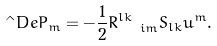Convert formula to latex. <formula><loc_0><loc_0><loc_500><loc_500>\hat { \ } D e P _ { m } = - \frac { 1 } { 2 } R ^ { l k } _ { \ \ i m } S _ { l k } u ^ { m } .</formula> 